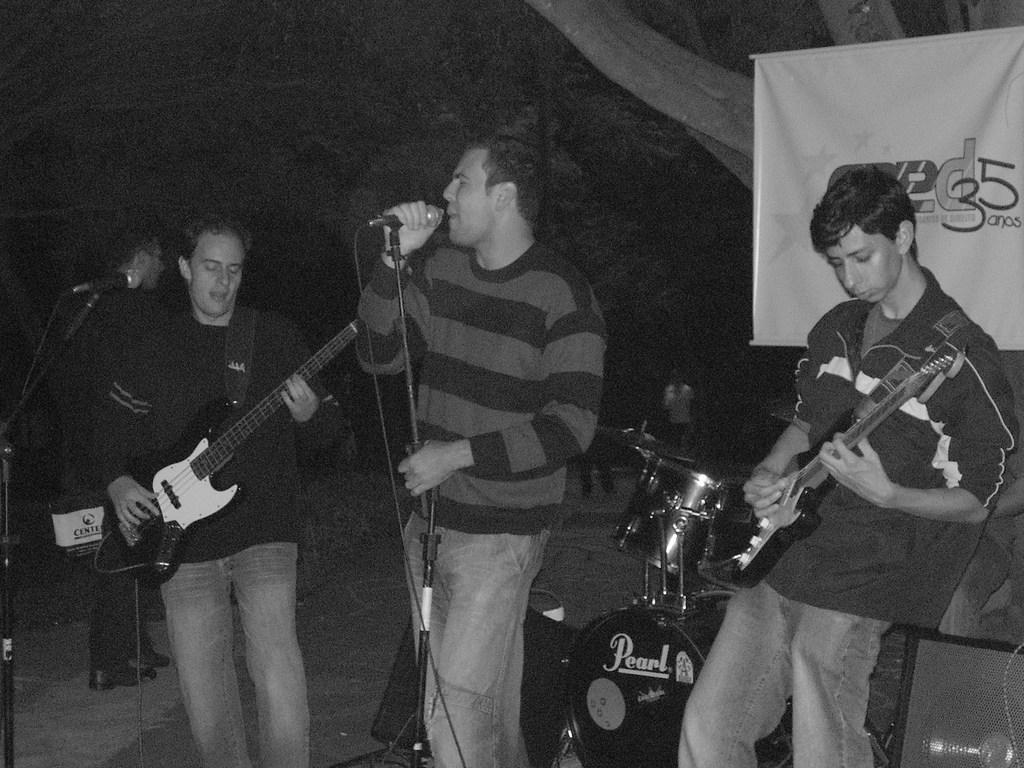Please provide a concise description of this image. This is a black and white picture. On the background we can see a banner. We can see three persons standing in front of a mike and playing musical instruments. This man is singing in a mic. These are drums. 